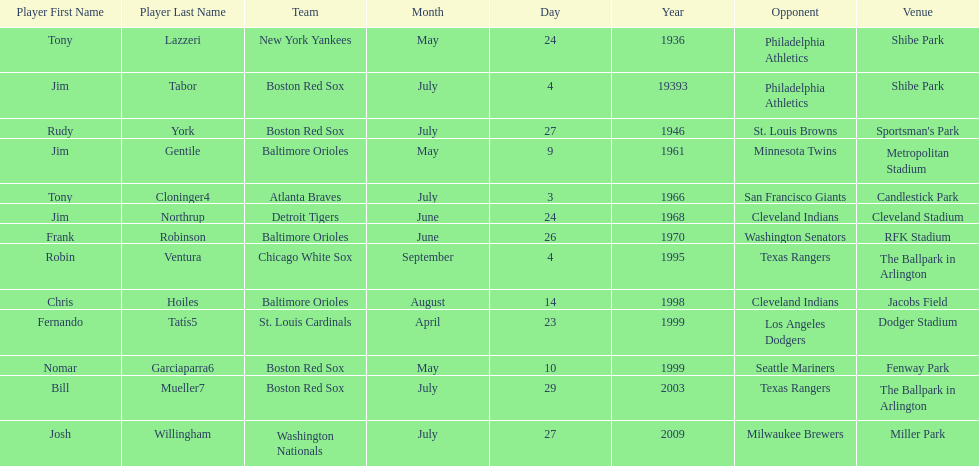What is the number of times a boston red sox player has had two grand slams in one game? 4. 